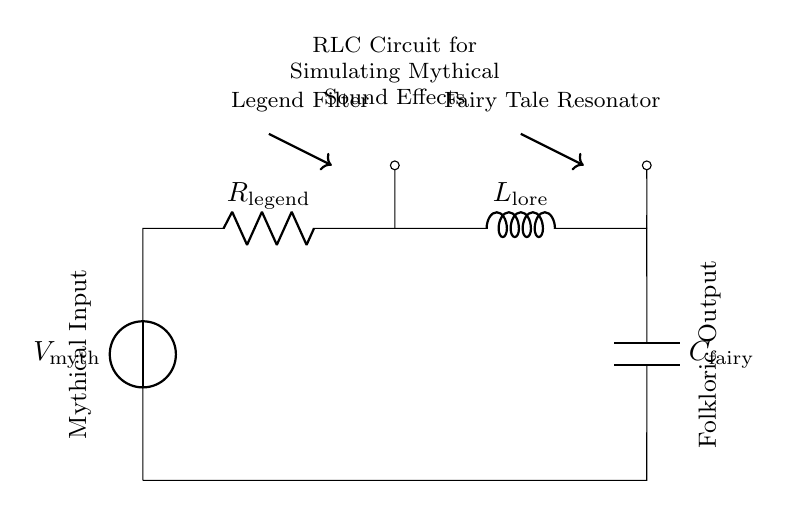What is the source voltage in this circuit? The source voltage, indicated as V mythical, is the voltage applied to the circuit to create the necessary mythical sound effects.
Answer: V mythical What type of components are in this circuit? The circuit contains three main components: a resistor, an inductor, and a capacitor, which are essential for creating the desired sound effects.
Answer: Resistor, inductor, capacitor What does the resistor represent in this folklore circuit? The resistor, labeled as R legend, represents a filter that adjusts the intensity of the sound effects related to the folklore, affecting how "legend" is conveyed.
Answer: Legend filter What is the role of the inductor in this configuration? The inductor, labeled as L lore, serves to store energy in a magnetic field and plays a critical role in tuning the circuit's response, ensuring that specific sound frequencies associated with stories are enhanced.
Answer: Fairy tale resonator What happens to the output when the capacitor is charged? When the capacitor, labeled as C fairy, is charged, it stores energy and, upon discharge, influences the timing and a variation of the sound output considered, enhancing the legendary effect of tales told.
Answer: Delayed sound effect How does the RLC circuit influence sound effects? The RLC circuit's combination of resistance, inductance, and capacitance allows it to selectively filter and resonate specific frequencies, which are crucial for creating varied mythical sound effects, impacting storytelling.
Answer: Frequency filtering 